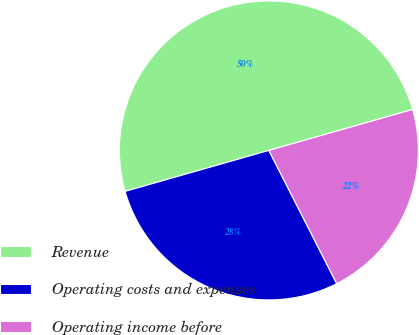Convert chart. <chart><loc_0><loc_0><loc_500><loc_500><pie_chart><fcel>Revenue<fcel>Operating costs and expenses<fcel>Operating income before<nl><fcel>50.0%<fcel>28.08%<fcel>21.92%<nl></chart> 